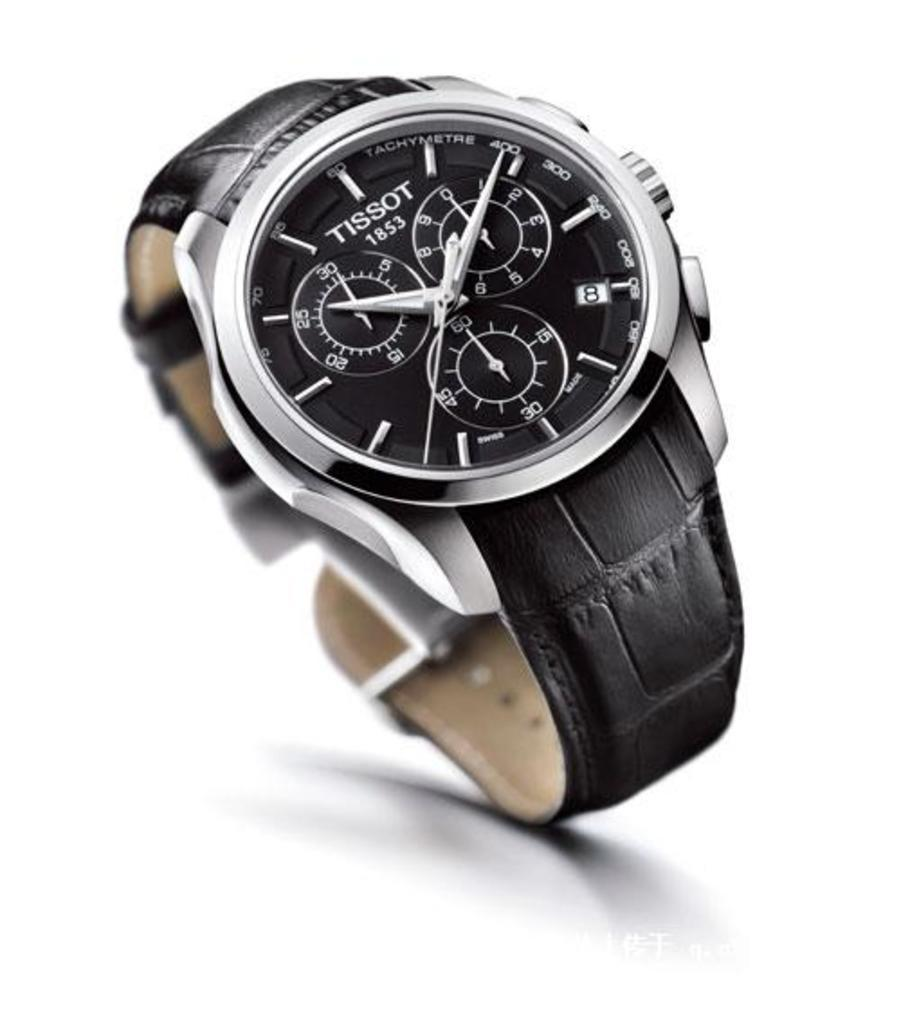What is the main subject of the image? The main subject of the image is a black color watch. Can you describe the location of the watch in the image? The watch is in the center of the image. What type of beef is being served under the umbrella in the image? There is no beef or umbrella present in the image; it only features a black color watch in the center. 